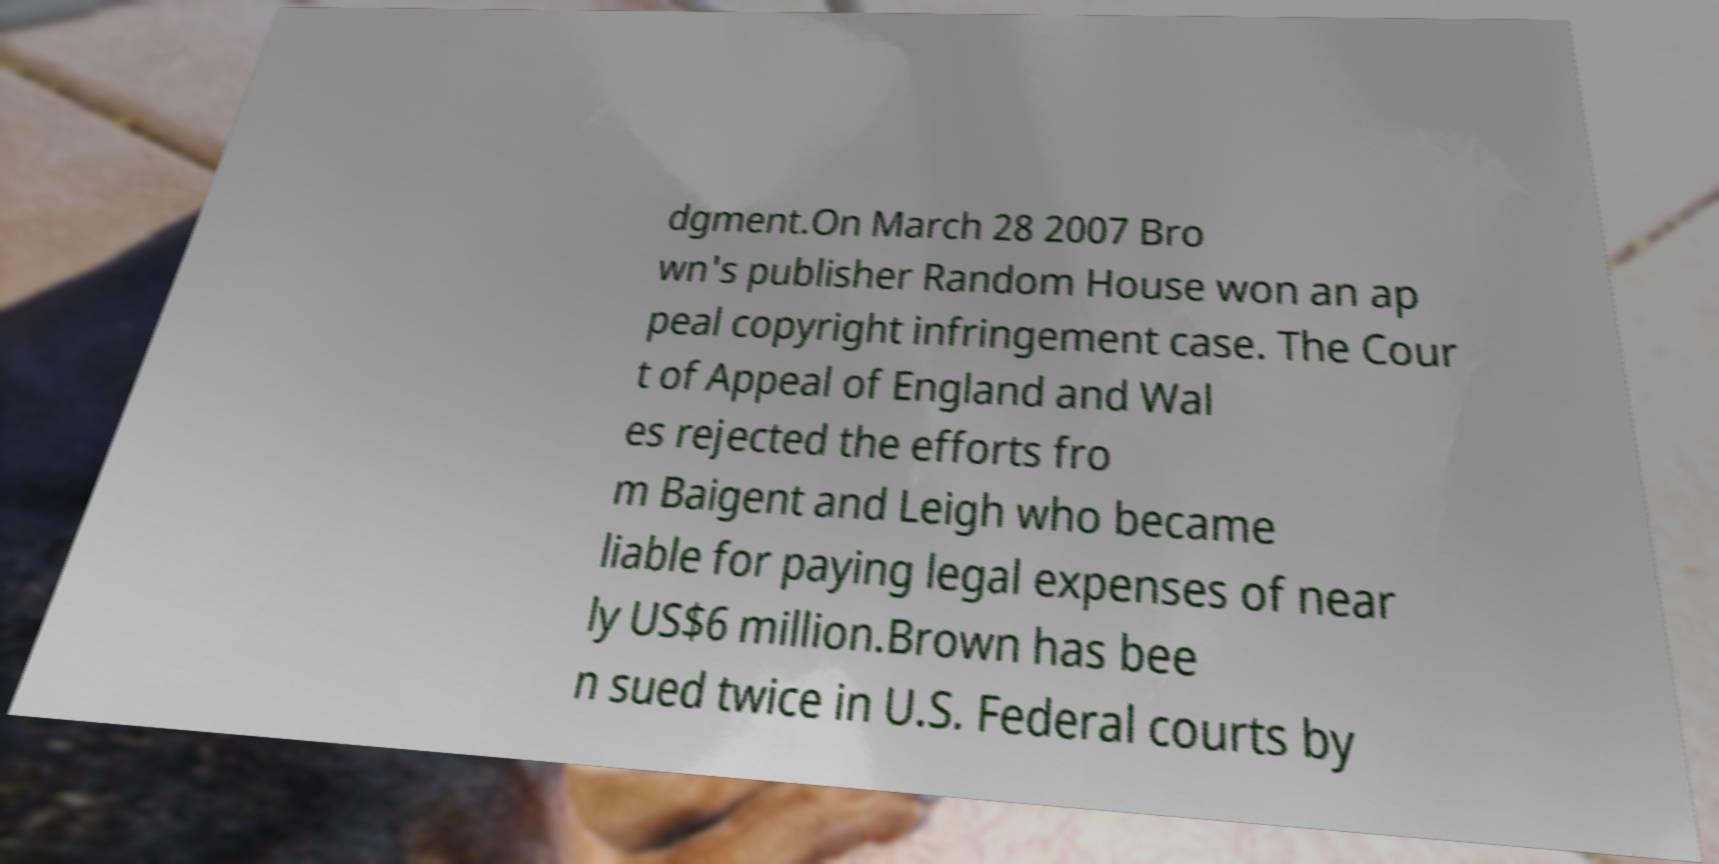Can you accurately transcribe the text from the provided image for me? dgment.On March 28 2007 Bro wn's publisher Random House won an ap peal copyright infringement case. The Cour t of Appeal of England and Wal es rejected the efforts fro m Baigent and Leigh who became liable for paying legal expenses of near ly US$6 million.Brown has bee n sued twice in U.S. Federal courts by 